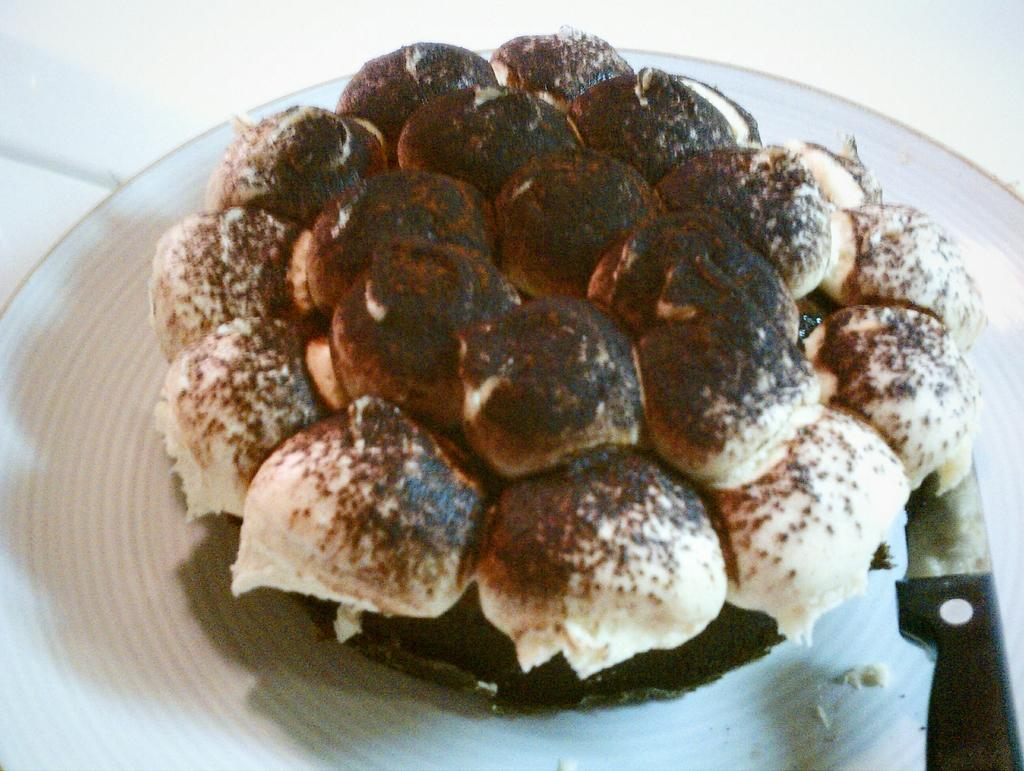What is on the plate that is visible in the image? There are scoops of ice cream on the plate in the image. What is the color of the ice cream? The ice cream has a brown color powder on it. What utensil is present in the image? There is a knife in the image. What is the color of the knife? The knife is black in color. What type of holiday is being celebrated in the image? There is no indication of a holiday being celebrated in the image. How many fingers are visible in the image? There are no fingers visible in the image; it only shows a plate with ice cream and a knife. 